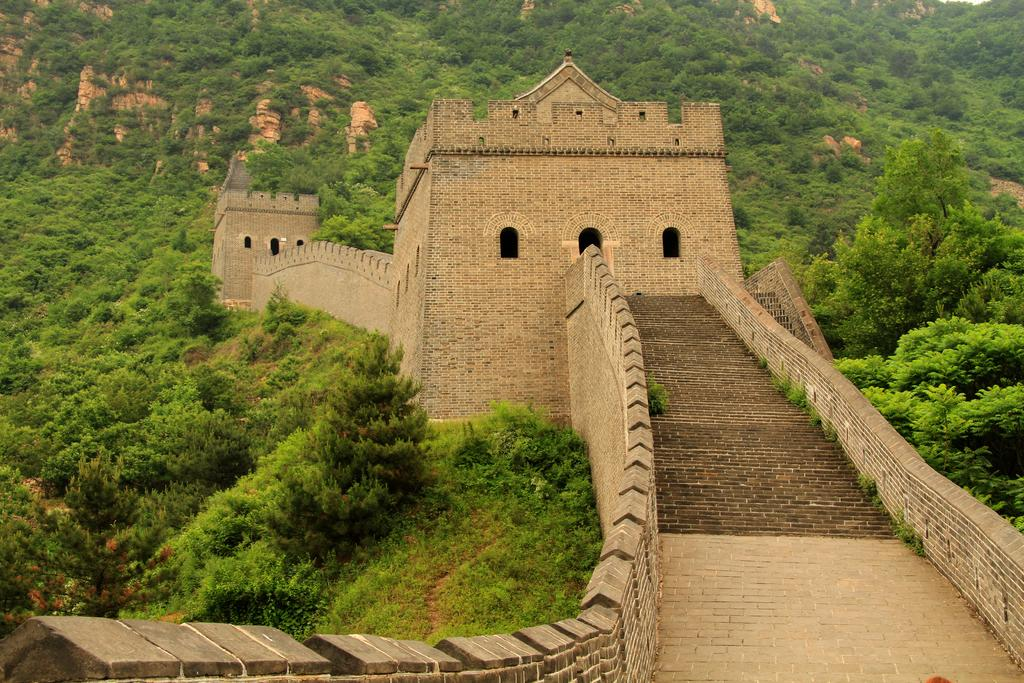What is the main structure in the image? There is a monument in the image. What type of natural elements can be seen in the image? There are trees in the image. What type of mask is hanging from the branches of the trees in the image? There is no mask present in the image; it only features a monument and trees. 